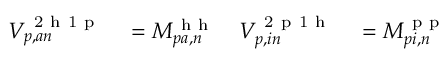Convert formula to latex. <formula><loc_0><loc_0><loc_500><loc_500>\begin{array} { r l r l } { V _ { p , a n } ^ { 2 h 1 p } } & = M _ { p a , n } ^ { h h } } & { V _ { p , i n } ^ { 2 p 1 h } } & = M _ { p i , n } ^ { p p } } \end{array}</formula> 